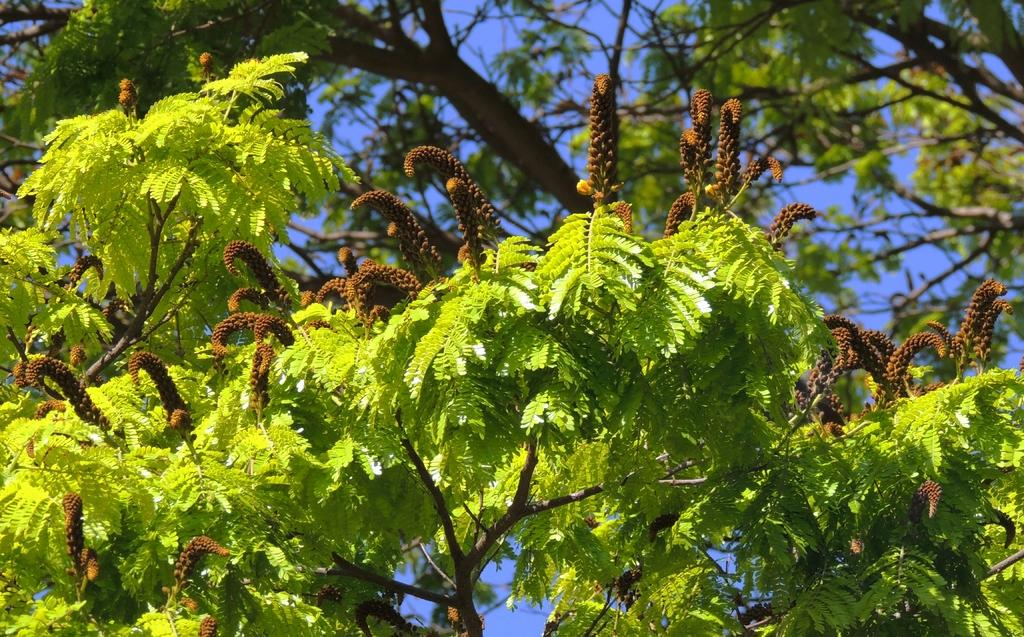What type of trees are in the foreground of the image? There are pine trees in the foreground of the image. What can be seen in the background of the image? The sky is visible in the background of the image. Can you see a toad climbing the pine trees in the image? There is no toad present in the image, and therefore no such activity can be observed. 